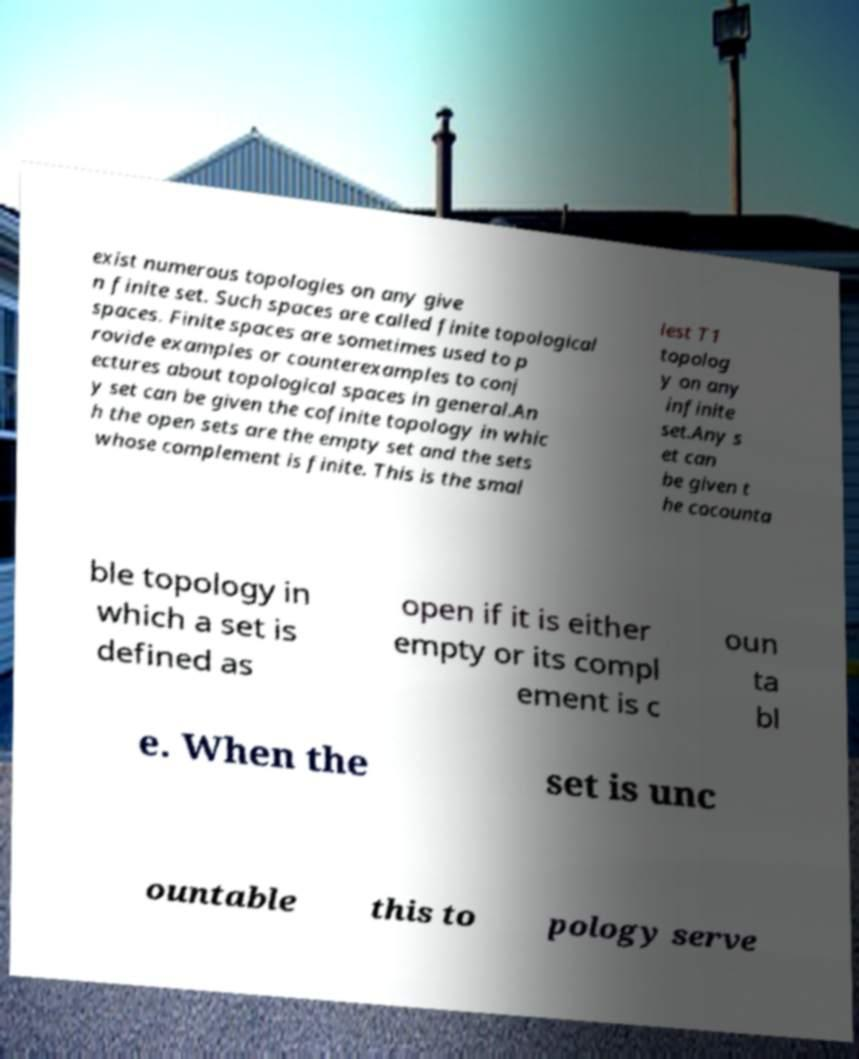Please read and relay the text visible in this image. What does it say? exist numerous topologies on any give n finite set. Such spaces are called finite topological spaces. Finite spaces are sometimes used to p rovide examples or counterexamples to conj ectures about topological spaces in general.An y set can be given the cofinite topology in whic h the open sets are the empty set and the sets whose complement is finite. This is the smal lest T1 topolog y on any infinite set.Any s et can be given t he cocounta ble topology in which a set is defined as open if it is either empty or its compl ement is c oun ta bl e. When the set is unc ountable this to pology serve 